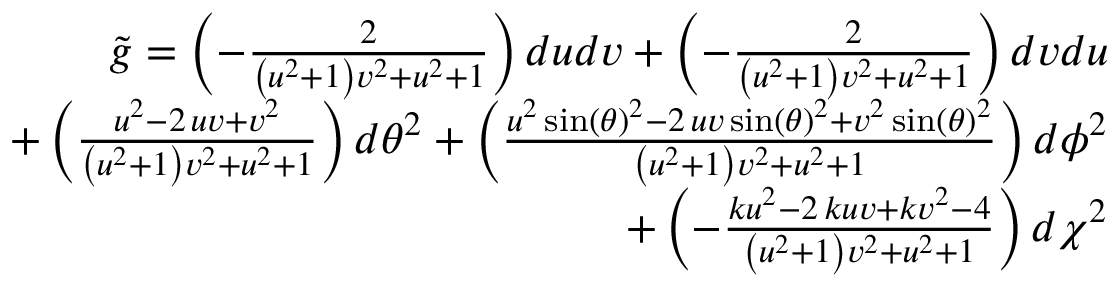Convert formula to latex. <formula><loc_0><loc_0><loc_500><loc_500>\begin{array} { r } { \tilde { g } = \left ( - \frac { 2 } { { \left ( u ^ { 2 } + 1 \right ) } v ^ { 2 } + u ^ { 2 } + 1 } \right ) d u d v + \left ( - \frac { 2 } { { \left ( u ^ { 2 } + 1 \right ) } v ^ { 2 } + u ^ { 2 } + 1 } \right ) d v d u } \\ { + \left ( \frac { u ^ { 2 } - 2 \, u v + v ^ { 2 } } { { \left ( u ^ { 2 } + 1 \right ) } v ^ { 2 } + u ^ { 2 } + 1 } \right ) d \theta ^ { 2 } + \left ( \frac { u ^ { 2 } \sin \left ( { \theta } \right ) ^ { 2 } - 2 \, u v \sin \left ( { \theta } \right ) ^ { 2 } + v ^ { 2 } \sin \left ( { \theta } \right ) ^ { 2 } } { { \left ( u ^ { 2 } + 1 \right ) } v ^ { 2 } + u ^ { 2 } + 1 } \right ) d \phi ^ { 2 } } \\ { + \left ( - \frac { k u ^ { 2 } - 2 \, k u v + k v ^ { 2 } - 4 } { { \left ( u ^ { 2 } + 1 \right ) } v ^ { 2 } + u ^ { 2 } + 1 } \right ) d \chi ^ { 2 } } \end{array}</formula> 